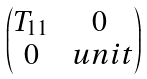Convert formula to latex. <formula><loc_0><loc_0><loc_500><loc_500>\begin{pmatrix} T _ { 1 1 } & 0 \\ 0 & \ u n i t \end{pmatrix}</formula> 